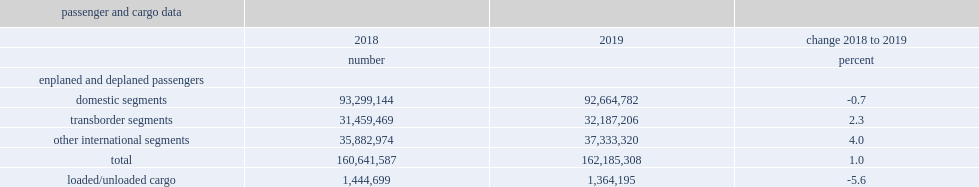What the percent did the weight of cargo loaded and unloaded at canadian airports decrease year-over-year in 2019? 5.6. 